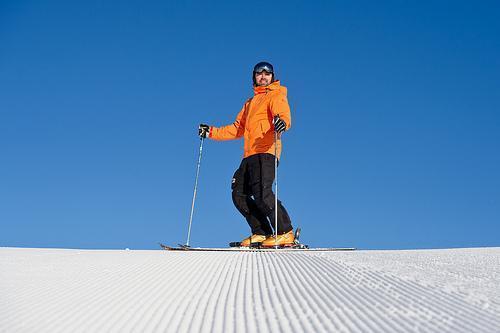How many guys are there?
Give a very brief answer. 1. 